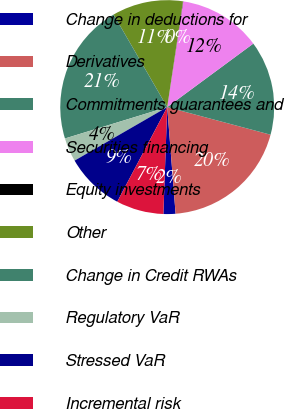<chart> <loc_0><loc_0><loc_500><loc_500><pie_chart><fcel>Change in deductions for<fcel>Derivatives<fcel>Commitments guarantees and<fcel>Securities financing<fcel>Equity investments<fcel>Other<fcel>Change in Credit RWAs<fcel>Regulatory VaR<fcel>Stressed VaR<fcel>Incremental risk<nl><fcel>1.82%<fcel>19.6%<fcel>14.27%<fcel>12.49%<fcel>0.04%<fcel>10.71%<fcel>21.38%<fcel>3.6%<fcel>8.93%<fcel>7.16%<nl></chart> 